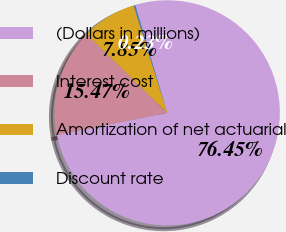Convert chart. <chart><loc_0><loc_0><loc_500><loc_500><pie_chart><fcel>(Dollars in millions)<fcel>Interest cost<fcel>Amortization of net actuarial<fcel>Discount rate<nl><fcel>76.45%<fcel>15.47%<fcel>7.85%<fcel>0.23%<nl></chart> 